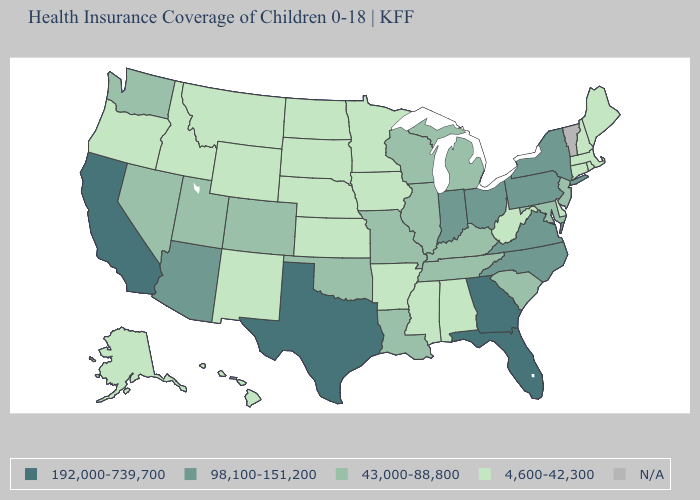Name the states that have a value in the range 192,000-739,700?
Short answer required. California, Florida, Georgia, Texas. What is the highest value in the South ?
Keep it brief. 192,000-739,700. What is the value of Wyoming?
Write a very short answer. 4,600-42,300. How many symbols are there in the legend?
Write a very short answer. 5. Name the states that have a value in the range 98,100-151,200?
Give a very brief answer. Arizona, Indiana, New York, North Carolina, Ohio, Pennsylvania, Virginia. Does Nebraska have the lowest value in the USA?
Short answer required. Yes. Name the states that have a value in the range 98,100-151,200?
Keep it brief. Arizona, Indiana, New York, North Carolina, Ohio, Pennsylvania, Virginia. What is the value of Alabama?
Concise answer only. 4,600-42,300. Does Virginia have the lowest value in the USA?
Keep it brief. No. What is the value of North Dakota?
Give a very brief answer. 4,600-42,300. Which states have the lowest value in the USA?
Quick response, please. Alabama, Alaska, Arkansas, Connecticut, Delaware, Hawaii, Idaho, Iowa, Kansas, Maine, Massachusetts, Minnesota, Mississippi, Montana, Nebraska, New Hampshire, New Mexico, North Dakota, Oregon, Rhode Island, South Dakota, West Virginia, Wyoming. Name the states that have a value in the range 43,000-88,800?
Be succinct. Colorado, Illinois, Kentucky, Louisiana, Maryland, Michigan, Missouri, Nevada, New Jersey, Oklahoma, South Carolina, Tennessee, Utah, Washington, Wisconsin. Which states have the lowest value in the USA?
Quick response, please. Alabama, Alaska, Arkansas, Connecticut, Delaware, Hawaii, Idaho, Iowa, Kansas, Maine, Massachusetts, Minnesota, Mississippi, Montana, Nebraska, New Hampshire, New Mexico, North Dakota, Oregon, Rhode Island, South Dakota, West Virginia, Wyoming. What is the lowest value in states that border Kentucky?
Concise answer only. 4,600-42,300. Does the first symbol in the legend represent the smallest category?
Give a very brief answer. No. 